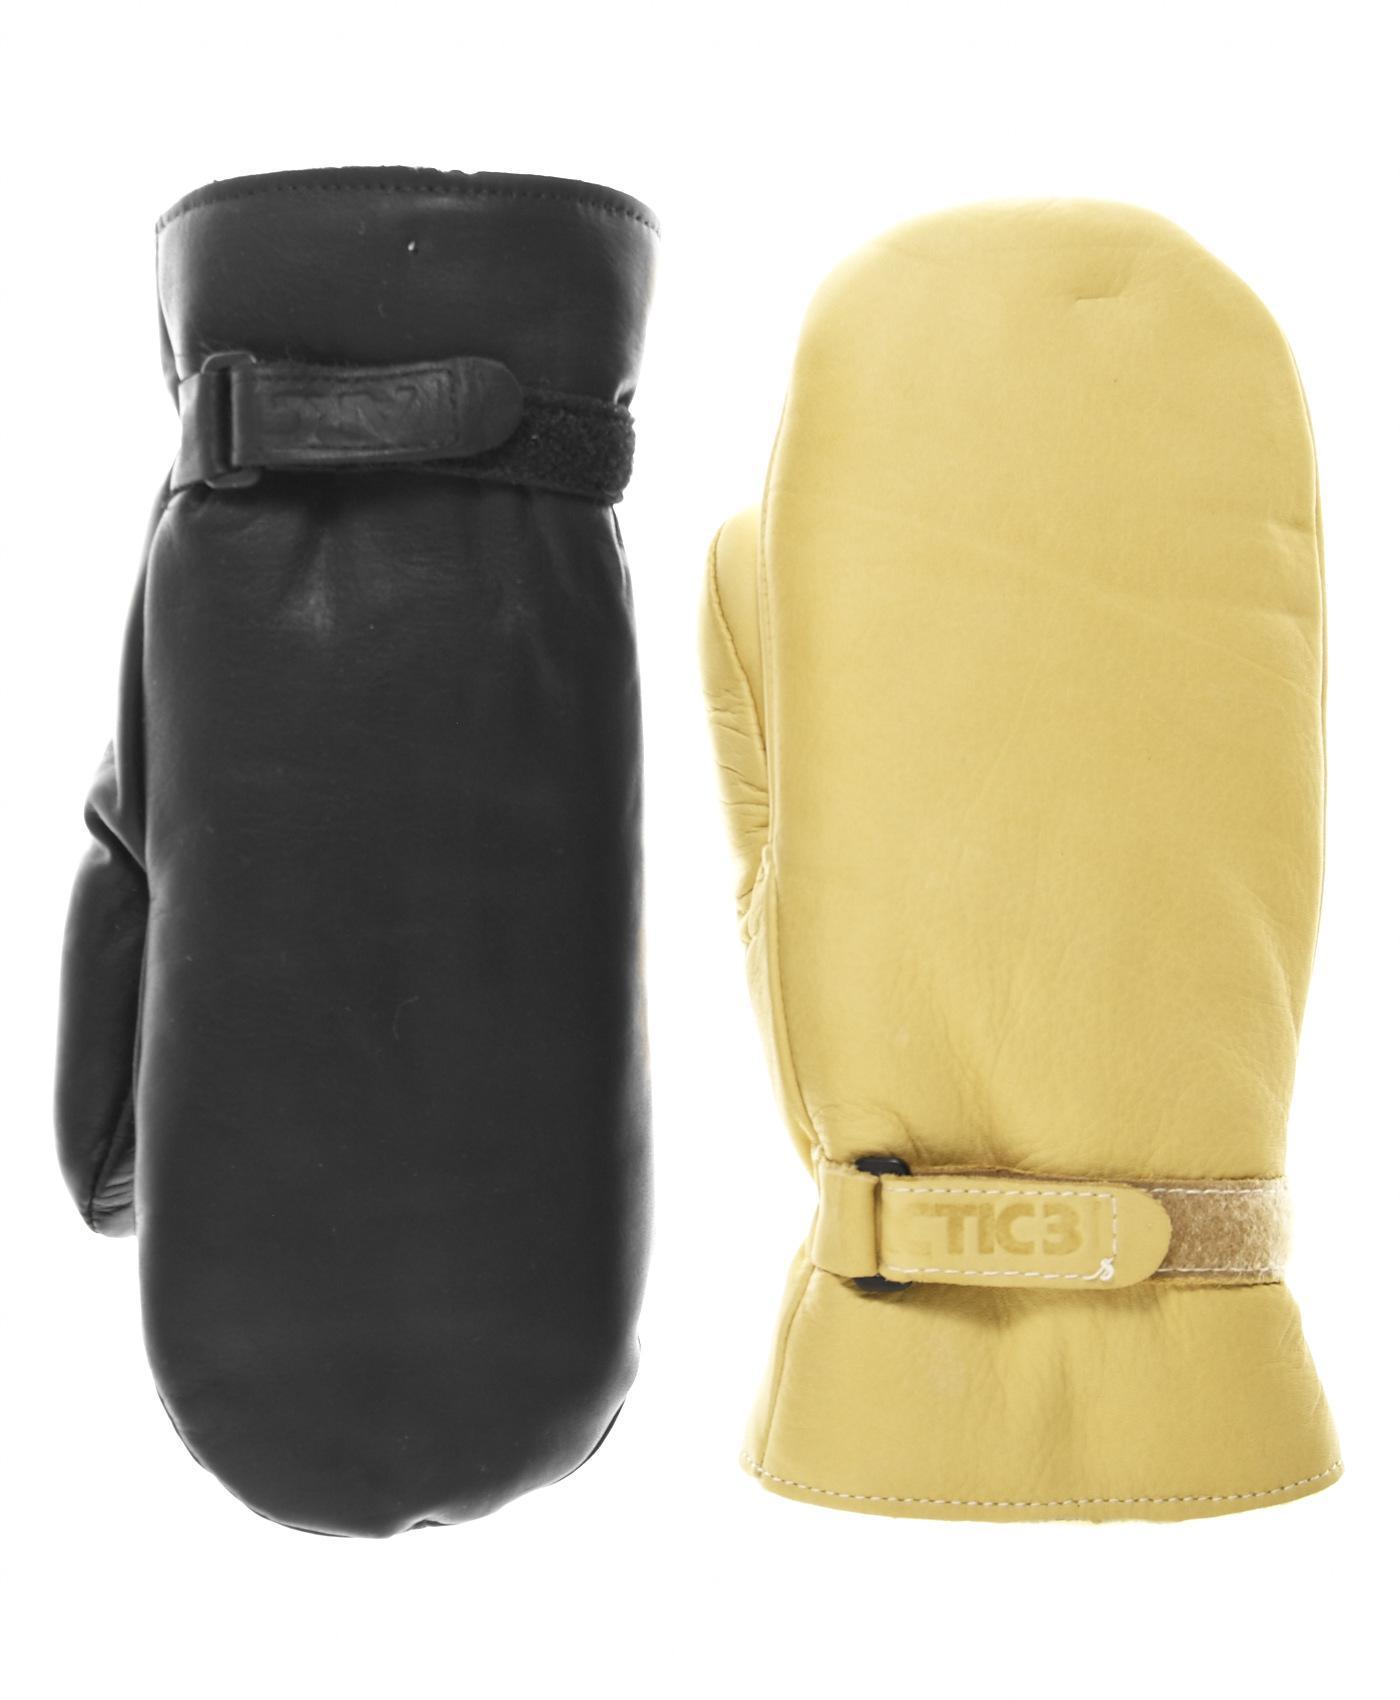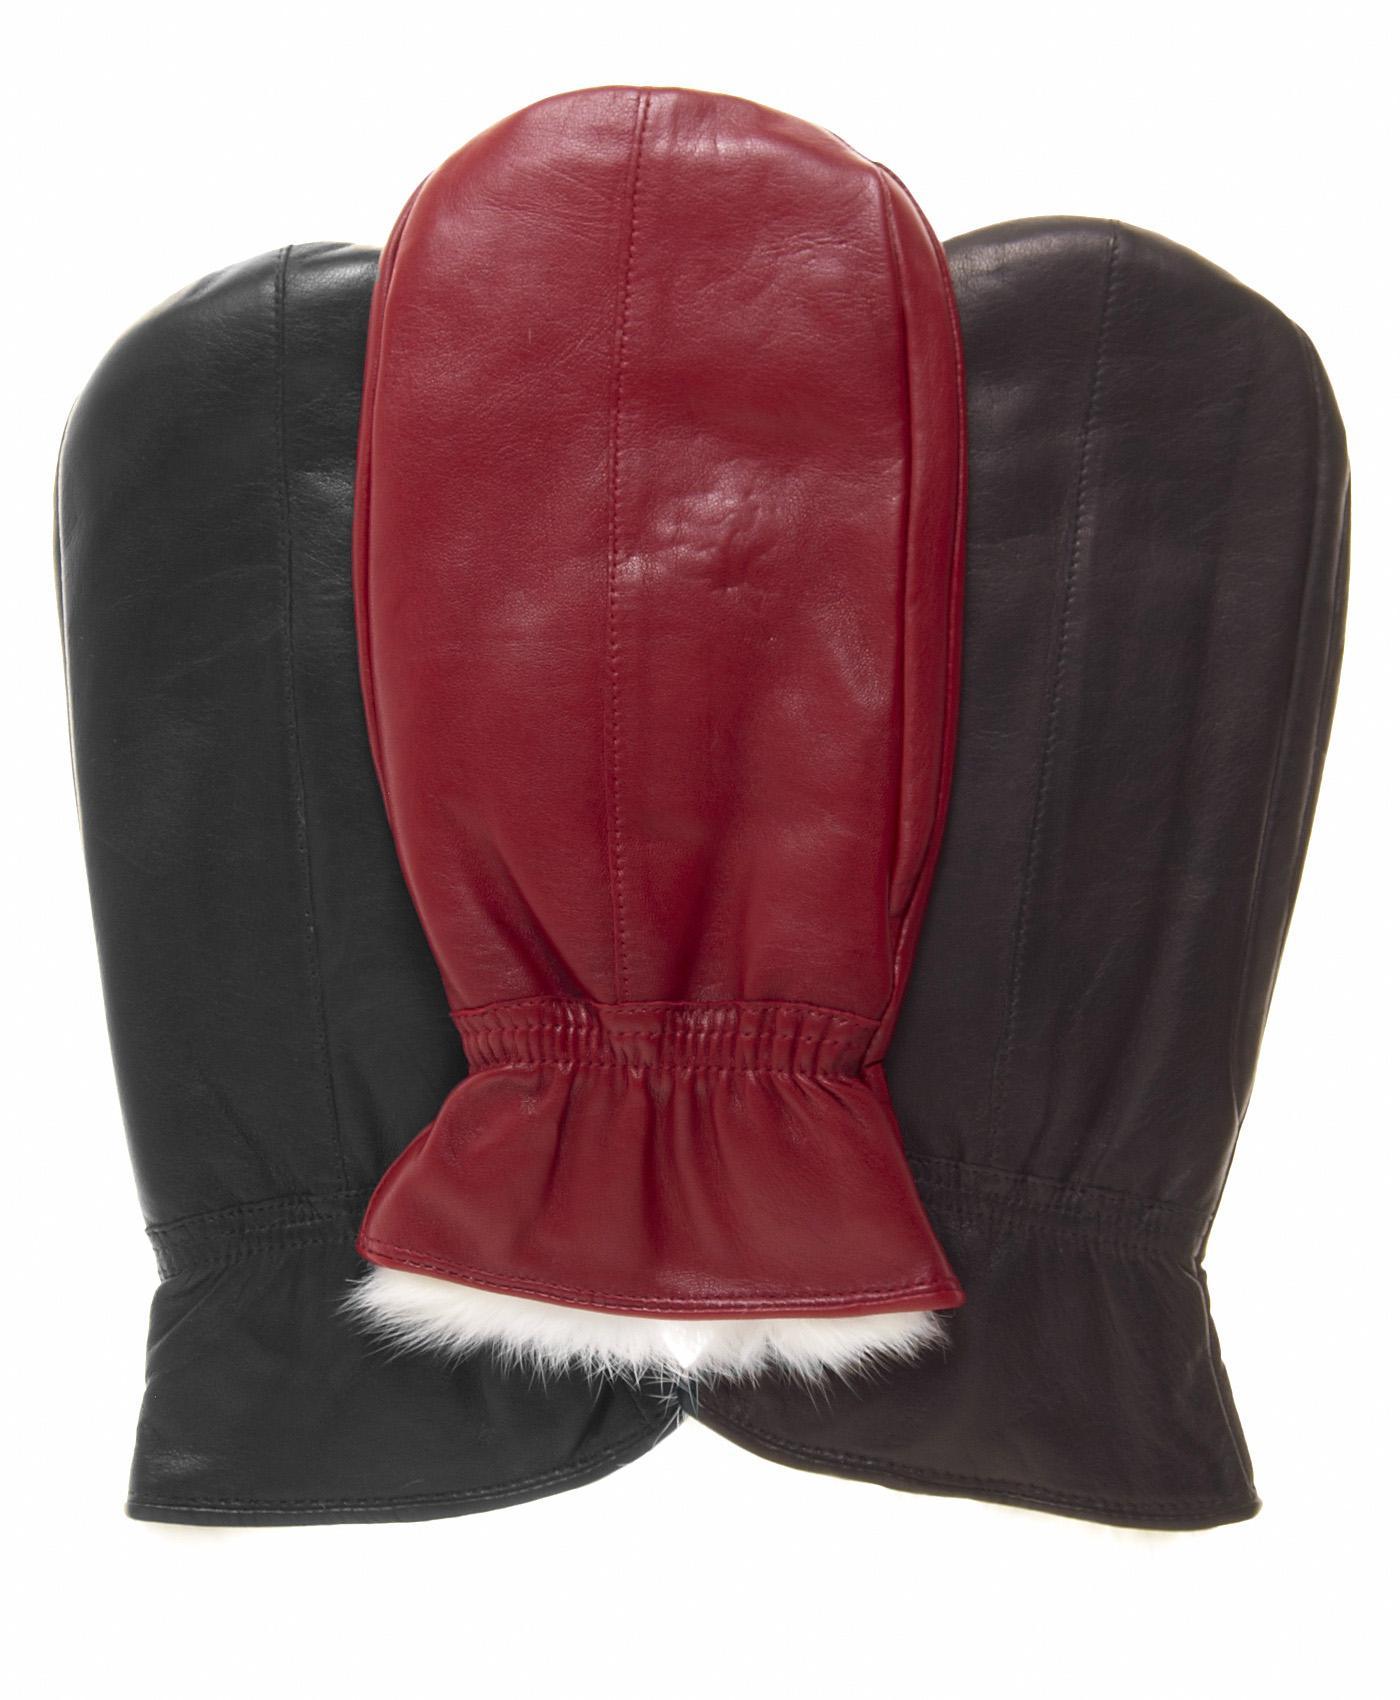The first image is the image on the left, the second image is the image on the right. Assess this claim about the two images: "One pair of dark brown leather mittens has elastic gathering around the wrists, and is displayed angled with one mitten facing each way.". Correct or not? Answer yes or no. No. The first image is the image on the left, the second image is the image on the right. Considering the images on both sides, is "Each image shows exactly two mittens, and each pair of mittens is displayed with the two mittens overlapping." valid? Answer yes or no. No. 